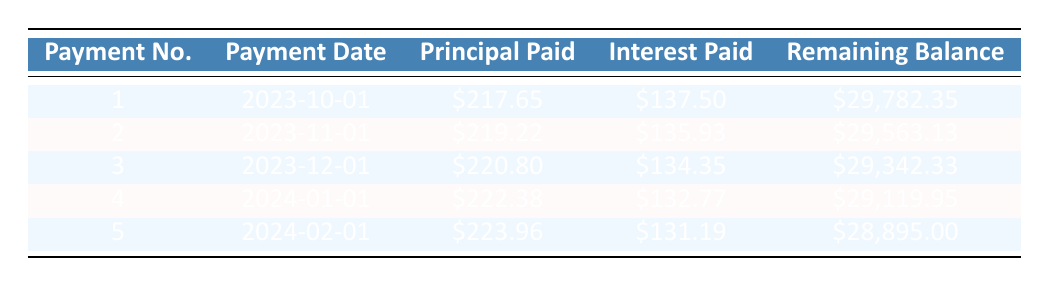What is the total loan amount for Sophia Johnson? The loan amount is specified in the loan details section as 30,000.
Answer: 30,000 How much interest was paid in the second payment? The interest paid for the second payment is shown in the table as 135.93.
Answer: 135.93 What is the remaining balance after the fifth payment? The remaining balance after the fifth payment is listed in the table as 28,895.00.
Answer: 28,895.00 What is the sum of principal paid for the first three payments? The principal paid for the first three payments is 217.65 + 219.22 + 220.80. Adding these amounts gives 217.65 + 219.22 = 436.87, then 436.87 + 220.80 = 657.67.
Answer: 657.67 Is the interest paid in the first payment greater than in the fourth payment? The interest paid in the first payment is 137.50, and for the fourth payment, it’s 132.77. Since 137.50 is greater than 132.77, the answer is yes.
Answer: Yes How much did Sophia pay towards the principal in total after the first two payments? The principal paid after the first two payments is 217.65 + 219.22. Summing these amounts gives 217.65 + 219.22 = 436.87.
Answer: 436.87 What is the average monthly payment amount for the first five payments? The monthly payment is constant at 322.65 for all payments. Since it’s the same for all five, the average is also 322.65.
Answer: 322.65 How much more principal was paid in the fifth payment compared to the first payment? The principal paid in the fifth payment is 223.96 and in the first payment is 217.65. The difference is 223.96 - 217.65 = 6.31.
Answer: 6.31 After the third payment, what is the total remaining balance? The remaining balance after the third payment is given in the table as 29,342.33.
Answer: 29,342.33 